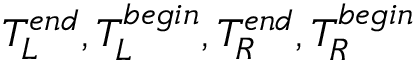<formula> <loc_0><loc_0><loc_500><loc_500>T _ { L } ^ { e n d } , T _ { L } ^ { b e g i n } , T _ { R } ^ { e n d } , T _ { R } ^ { b e g i n }</formula> 